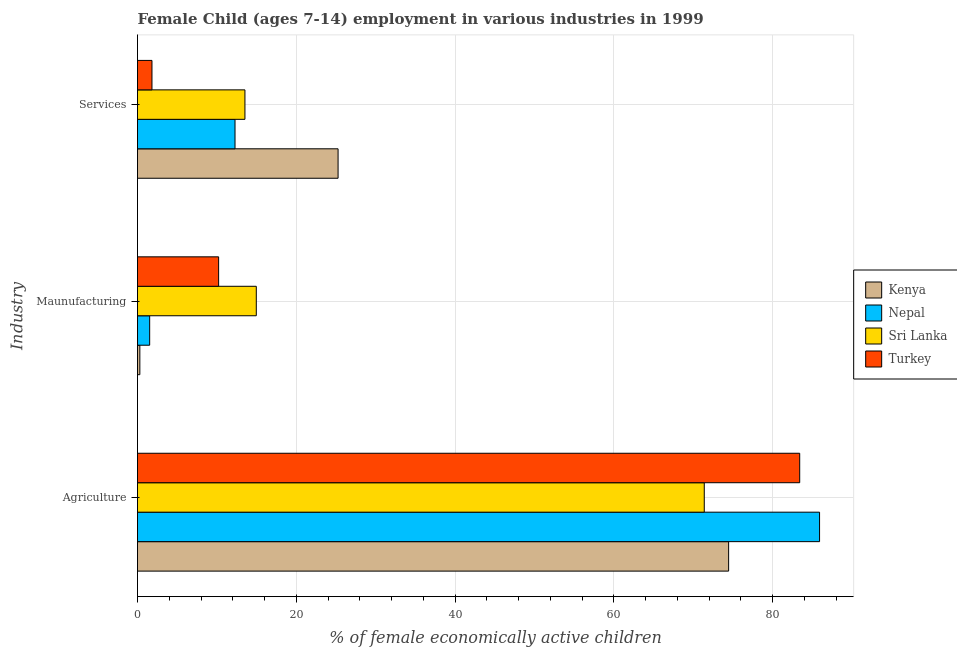How many groups of bars are there?
Offer a terse response. 3. What is the label of the 1st group of bars from the top?
Ensure brevity in your answer.  Services. What is the percentage of economically active children in agriculture in Turkey?
Keep it short and to the point. 83.4. Across all countries, what is the maximum percentage of economically active children in agriculture?
Your response must be concise. 85.9. Across all countries, what is the minimum percentage of economically active children in manufacturing?
Offer a very short reply. 0.29. In which country was the percentage of economically active children in services maximum?
Provide a succinct answer. Kenya. In which country was the percentage of economically active children in manufacturing minimum?
Keep it short and to the point. Kenya. What is the total percentage of economically active children in manufacturing in the graph?
Your answer should be very brief. 27. What is the difference between the percentage of economically active children in services in Kenya and that in Sri Lanka?
Your response must be concise. 11.73. What is the difference between the percentage of economically active children in manufacturing in Nepal and the percentage of economically active children in agriculture in Turkey?
Your answer should be compact. -81.87. What is the average percentage of economically active children in manufacturing per country?
Your response must be concise. 6.75. What is the difference between the percentage of economically active children in services and percentage of economically active children in agriculture in Kenya?
Make the answer very short. -49.19. What is the ratio of the percentage of economically active children in manufacturing in Sri Lanka to that in Turkey?
Make the answer very short. 1.46. Is the difference between the percentage of economically active children in services in Sri Lanka and Turkey greater than the difference between the percentage of economically active children in manufacturing in Sri Lanka and Turkey?
Your answer should be compact. Yes. What is the difference between the highest and the second highest percentage of economically active children in agriculture?
Offer a very short reply. 2.5. What is the difference between the highest and the lowest percentage of economically active children in services?
Give a very brief answer. 23.44. In how many countries, is the percentage of economically active children in manufacturing greater than the average percentage of economically active children in manufacturing taken over all countries?
Ensure brevity in your answer.  2. Is the sum of the percentage of economically active children in agriculture in Sri Lanka and Turkey greater than the maximum percentage of economically active children in manufacturing across all countries?
Your response must be concise. Yes. What does the 2nd bar from the top in Maunufacturing represents?
Keep it short and to the point. Sri Lanka. Is it the case that in every country, the sum of the percentage of economically active children in agriculture and percentage of economically active children in manufacturing is greater than the percentage of economically active children in services?
Provide a short and direct response. Yes. How many bars are there?
Provide a short and direct response. 12. Are all the bars in the graph horizontal?
Provide a succinct answer. Yes. What is the difference between two consecutive major ticks on the X-axis?
Keep it short and to the point. 20. Does the graph contain any zero values?
Make the answer very short. No. How many legend labels are there?
Provide a short and direct response. 4. What is the title of the graph?
Your answer should be compact. Female Child (ages 7-14) employment in various industries in 1999. What is the label or title of the X-axis?
Offer a very short reply. % of female economically active children. What is the label or title of the Y-axis?
Your response must be concise. Industry. What is the % of female economically active children of Kenya in Agriculture?
Provide a short and direct response. 74.45. What is the % of female economically active children in Nepal in Agriculture?
Keep it short and to the point. 85.9. What is the % of female economically active children in Sri Lanka in Agriculture?
Offer a terse response. 71.38. What is the % of female economically active children in Turkey in Agriculture?
Offer a terse response. 83.4. What is the % of female economically active children of Kenya in Maunufacturing?
Offer a terse response. 0.29. What is the % of female economically active children in Nepal in Maunufacturing?
Ensure brevity in your answer.  1.53. What is the % of female economically active children of Sri Lanka in Maunufacturing?
Your answer should be compact. 14.96. What is the % of female economically active children in Turkey in Maunufacturing?
Offer a very short reply. 10.22. What is the % of female economically active children of Kenya in Services?
Provide a short and direct response. 25.26. What is the % of female economically active children of Nepal in Services?
Ensure brevity in your answer.  12.28. What is the % of female economically active children of Sri Lanka in Services?
Offer a very short reply. 13.53. What is the % of female economically active children of Turkey in Services?
Your response must be concise. 1.82. Across all Industry, what is the maximum % of female economically active children of Kenya?
Keep it short and to the point. 74.45. Across all Industry, what is the maximum % of female economically active children of Nepal?
Provide a succinct answer. 85.9. Across all Industry, what is the maximum % of female economically active children in Sri Lanka?
Ensure brevity in your answer.  71.38. Across all Industry, what is the maximum % of female economically active children in Turkey?
Offer a very short reply. 83.4. Across all Industry, what is the minimum % of female economically active children in Kenya?
Offer a terse response. 0.29. Across all Industry, what is the minimum % of female economically active children of Nepal?
Offer a very short reply. 1.53. Across all Industry, what is the minimum % of female economically active children of Sri Lanka?
Your response must be concise. 13.53. Across all Industry, what is the minimum % of female economically active children in Turkey?
Make the answer very short. 1.82. What is the total % of female economically active children of Kenya in the graph?
Provide a succinct answer. 100. What is the total % of female economically active children in Nepal in the graph?
Offer a very short reply. 99.71. What is the total % of female economically active children in Sri Lanka in the graph?
Your answer should be compact. 99.87. What is the total % of female economically active children in Turkey in the graph?
Your response must be concise. 95.44. What is the difference between the % of female economically active children in Kenya in Agriculture and that in Maunufacturing?
Your response must be concise. 74.15. What is the difference between the % of female economically active children of Nepal in Agriculture and that in Maunufacturing?
Offer a terse response. 84.37. What is the difference between the % of female economically active children of Sri Lanka in Agriculture and that in Maunufacturing?
Ensure brevity in your answer.  56.42. What is the difference between the % of female economically active children of Turkey in Agriculture and that in Maunufacturing?
Offer a very short reply. 73.18. What is the difference between the % of female economically active children of Kenya in Agriculture and that in Services?
Give a very brief answer. 49.19. What is the difference between the % of female economically active children of Nepal in Agriculture and that in Services?
Offer a terse response. 73.62. What is the difference between the % of female economically active children of Sri Lanka in Agriculture and that in Services?
Keep it short and to the point. 57.85. What is the difference between the % of female economically active children in Turkey in Agriculture and that in Services?
Give a very brief answer. 81.58. What is the difference between the % of female economically active children of Kenya in Maunufacturing and that in Services?
Keep it short and to the point. -24.97. What is the difference between the % of female economically active children in Nepal in Maunufacturing and that in Services?
Keep it short and to the point. -10.75. What is the difference between the % of female economically active children of Sri Lanka in Maunufacturing and that in Services?
Keep it short and to the point. 1.43. What is the difference between the % of female economically active children of Turkey in Maunufacturing and that in Services?
Offer a very short reply. 8.39. What is the difference between the % of female economically active children in Kenya in Agriculture and the % of female economically active children in Nepal in Maunufacturing?
Make the answer very short. 72.91. What is the difference between the % of female economically active children of Kenya in Agriculture and the % of female economically active children of Sri Lanka in Maunufacturing?
Offer a very short reply. 59.49. What is the difference between the % of female economically active children of Kenya in Agriculture and the % of female economically active children of Turkey in Maunufacturing?
Make the answer very short. 64.23. What is the difference between the % of female economically active children of Nepal in Agriculture and the % of female economically active children of Sri Lanka in Maunufacturing?
Offer a terse response. 70.94. What is the difference between the % of female economically active children in Nepal in Agriculture and the % of female economically active children in Turkey in Maunufacturing?
Offer a terse response. 75.68. What is the difference between the % of female economically active children in Sri Lanka in Agriculture and the % of female economically active children in Turkey in Maunufacturing?
Ensure brevity in your answer.  61.16. What is the difference between the % of female economically active children in Kenya in Agriculture and the % of female economically active children in Nepal in Services?
Offer a very short reply. 62.17. What is the difference between the % of female economically active children in Kenya in Agriculture and the % of female economically active children in Sri Lanka in Services?
Your response must be concise. 60.92. What is the difference between the % of female economically active children of Kenya in Agriculture and the % of female economically active children of Turkey in Services?
Your response must be concise. 72.62. What is the difference between the % of female economically active children of Nepal in Agriculture and the % of female economically active children of Sri Lanka in Services?
Keep it short and to the point. 72.37. What is the difference between the % of female economically active children in Nepal in Agriculture and the % of female economically active children in Turkey in Services?
Your response must be concise. 84.08. What is the difference between the % of female economically active children in Sri Lanka in Agriculture and the % of female economically active children in Turkey in Services?
Your answer should be very brief. 69.56. What is the difference between the % of female economically active children of Kenya in Maunufacturing and the % of female economically active children of Nepal in Services?
Your response must be concise. -11.99. What is the difference between the % of female economically active children of Kenya in Maunufacturing and the % of female economically active children of Sri Lanka in Services?
Provide a short and direct response. -13.24. What is the difference between the % of female economically active children in Kenya in Maunufacturing and the % of female economically active children in Turkey in Services?
Make the answer very short. -1.53. What is the difference between the % of female economically active children in Nepal in Maunufacturing and the % of female economically active children in Sri Lanka in Services?
Ensure brevity in your answer.  -12. What is the difference between the % of female economically active children of Nepal in Maunufacturing and the % of female economically active children of Turkey in Services?
Make the answer very short. -0.29. What is the difference between the % of female economically active children of Sri Lanka in Maunufacturing and the % of female economically active children of Turkey in Services?
Offer a very short reply. 13.14. What is the average % of female economically active children in Kenya per Industry?
Your response must be concise. 33.33. What is the average % of female economically active children of Nepal per Industry?
Offer a very short reply. 33.24. What is the average % of female economically active children of Sri Lanka per Industry?
Make the answer very short. 33.29. What is the average % of female economically active children of Turkey per Industry?
Provide a short and direct response. 31.81. What is the difference between the % of female economically active children in Kenya and % of female economically active children in Nepal in Agriculture?
Your answer should be compact. -11.45. What is the difference between the % of female economically active children of Kenya and % of female economically active children of Sri Lanka in Agriculture?
Your answer should be compact. 3.07. What is the difference between the % of female economically active children of Kenya and % of female economically active children of Turkey in Agriculture?
Give a very brief answer. -8.95. What is the difference between the % of female economically active children of Nepal and % of female economically active children of Sri Lanka in Agriculture?
Keep it short and to the point. 14.52. What is the difference between the % of female economically active children of Nepal and % of female economically active children of Turkey in Agriculture?
Give a very brief answer. 2.5. What is the difference between the % of female economically active children in Sri Lanka and % of female economically active children in Turkey in Agriculture?
Your answer should be compact. -12.02. What is the difference between the % of female economically active children of Kenya and % of female economically active children of Nepal in Maunufacturing?
Give a very brief answer. -1.24. What is the difference between the % of female economically active children of Kenya and % of female economically active children of Sri Lanka in Maunufacturing?
Offer a terse response. -14.67. What is the difference between the % of female economically active children of Kenya and % of female economically active children of Turkey in Maunufacturing?
Ensure brevity in your answer.  -9.92. What is the difference between the % of female economically active children in Nepal and % of female economically active children in Sri Lanka in Maunufacturing?
Offer a very short reply. -13.43. What is the difference between the % of female economically active children of Nepal and % of female economically active children of Turkey in Maunufacturing?
Your response must be concise. -8.68. What is the difference between the % of female economically active children of Sri Lanka and % of female economically active children of Turkey in Maunufacturing?
Your answer should be compact. 4.74. What is the difference between the % of female economically active children of Kenya and % of female economically active children of Nepal in Services?
Your answer should be very brief. 12.98. What is the difference between the % of female economically active children in Kenya and % of female economically active children in Sri Lanka in Services?
Your answer should be very brief. 11.73. What is the difference between the % of female economically active children of Kenya and % of female economically active children of Turkey in Services?
Offer a very short reply. 23.44. What is the difference between the % of female economically active children of Nepal and % of female economically active children of Sri Lanka in Services?
Your response must be concise. -1.25. What is the difference between the % of female economically active children of Nepal and % of female economically active children of Turkey in Services?
Your answer should be compact. 10.46. What is the difference between the % of female economically active children of Sri Lanka and % of female economically active children of Turkey in Services?
Make the answer very short. 11.71. What is the ratio of the % of female economically active children in Kenya in Agriculture to that in Maunufacturing?
Your response must be concise. 253.97. What is the ratio of the % of female economically active children of Nepal in Agriculture to that in Maunufacturing?
Provide a succinct answer. 56.08. What is the ratio of the % of female economically active children in Sri Lanka in Agriculture to that in Maunufacturing?
Make the answer very short. 4.77. What is the ratio of the % of female economically active children in Turkey in Agriculture to that in Maunufacturing?
Your answer should be very brief. 8.16. What is the ratio of the % of female economically active children of Kenya in Agriculture to that in Services?
Keep it short and to the point. 2.95. What is the ratio of the % of female economically active children of Nepal in Agriculture to that in Services?
Offer a very short reply. 7. What is the ratio of the % of female economically active children of Sri Lanka in Agriculture to that in Services?
Give a very brief answer. 5.28. What is the ratio of the % of female economically active children of Turkey in Agriculture to that in Services?
Provide a short and direct response. 45.79. What is the ratio of the % of female economically active children of Kenya in Maunufacturing to that in Services?
Make the answer very short. 0.01. What is the ratio of the % of female economically active children of Nepal in Maunufacturing to that in Services?
Your answer should be very brief. 0.12. What is the ratio of the % of female economically active children of Sri Lanka in Maunufacturing to that in Services?
Your response must be concise. 1.11. What is the ratio of the % of female economically active children of Turkey in Maunufacturing to that in Services?
Make the answer very short. 5.61. What is the difference between the highest and the second highest % of female economically active children of Kenya?
Give a very brief answer. 49.19. What is the difference between the highest and the second highest % of female economically active children of Nepal?
Provide a short and direct response. 73.62. What is the difference between the highest and the second highest % of female economically active children of Sri Lanka?
Ensure brevity in your answer.  56.42. What is the difference between the highest and the second highest % of female economically active children in Turkey?
Make the answer very short. 73.18. What is the difference between the highest and the lowest % of female economically active children of Kenya?
Make the answer very short. 74.15. What is the difference between the highest and the lowest % of female economically active children in Nepal?
Your answer should be compact. 84.37. What is the difference between the highest and the lowest % of female economically active children in Sri Lanka?
Your answer should be very brief. 57.85. What is the difference between the highest and the lowest % of female economically active children of Turkey?
Offer a terse response. 81.58. 